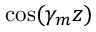<formula> <loc_0><loc_0><loc_500><loc_500>\cos ( \gamma _ { m } z )</formula> 